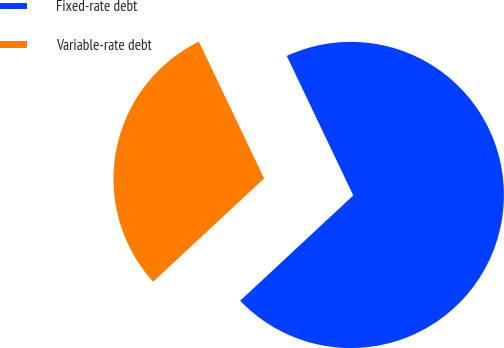Convert chart. <chart><loc_0><loc_0><loc_500><loc_500><pie_chart><fcel>Fixed-rate debt<fcel>Variable-rate debt<nl><fcel>70.15%<fcel>29.85%<nl></chart> 